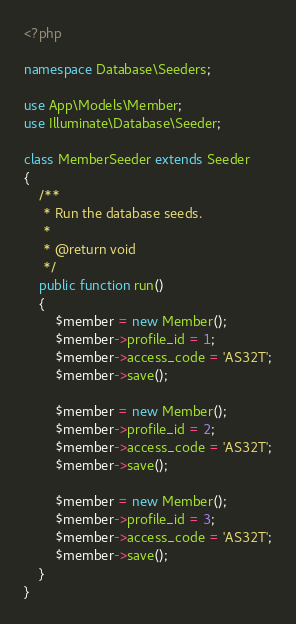Convert code to text. <code><loc_0><loc_0><loc_500><loc_500><_PHP_><?php

namespace Database\Seeders;

use App\Models\Member;
use Illuminate\Database\Seeder;

class MemberSeeder extends Seeder
{
    /**
     * Run the database seeds.
     *
     * @return void
     */
    public function run()
    {
        $member = new Member();
        $member->profile_id = 1;
        $member->access_code = 'AS32T';
        $member->save();

        $member = new Member();
        $member->profile_id = 2;
        $member->access_code = 'AS32T';
        $member->save();

        $member = new Member();
        $member->profile_id = 3;
        $member->access_code = 'AS32T';
        $member->save();
    }
}
</code> 